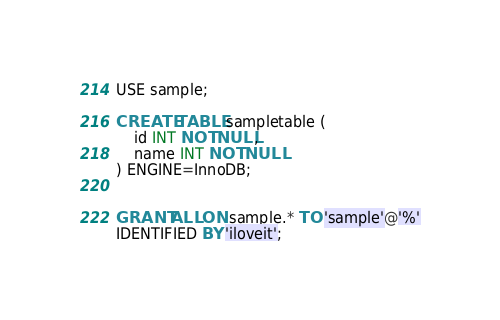Convert code to text. <code><loc_0><loc_0><loc_500><loc_500><_SQL_>USE sample;

CREATE TABLE sampletable (
    id INT NOT NULL,
    name INT NOT NULL
) ENGINE=InnoDB;


GRANT ALL ON sample.* TO 'sample'@'%'
IDENTIFIED BY 'iloveit';

</code> 